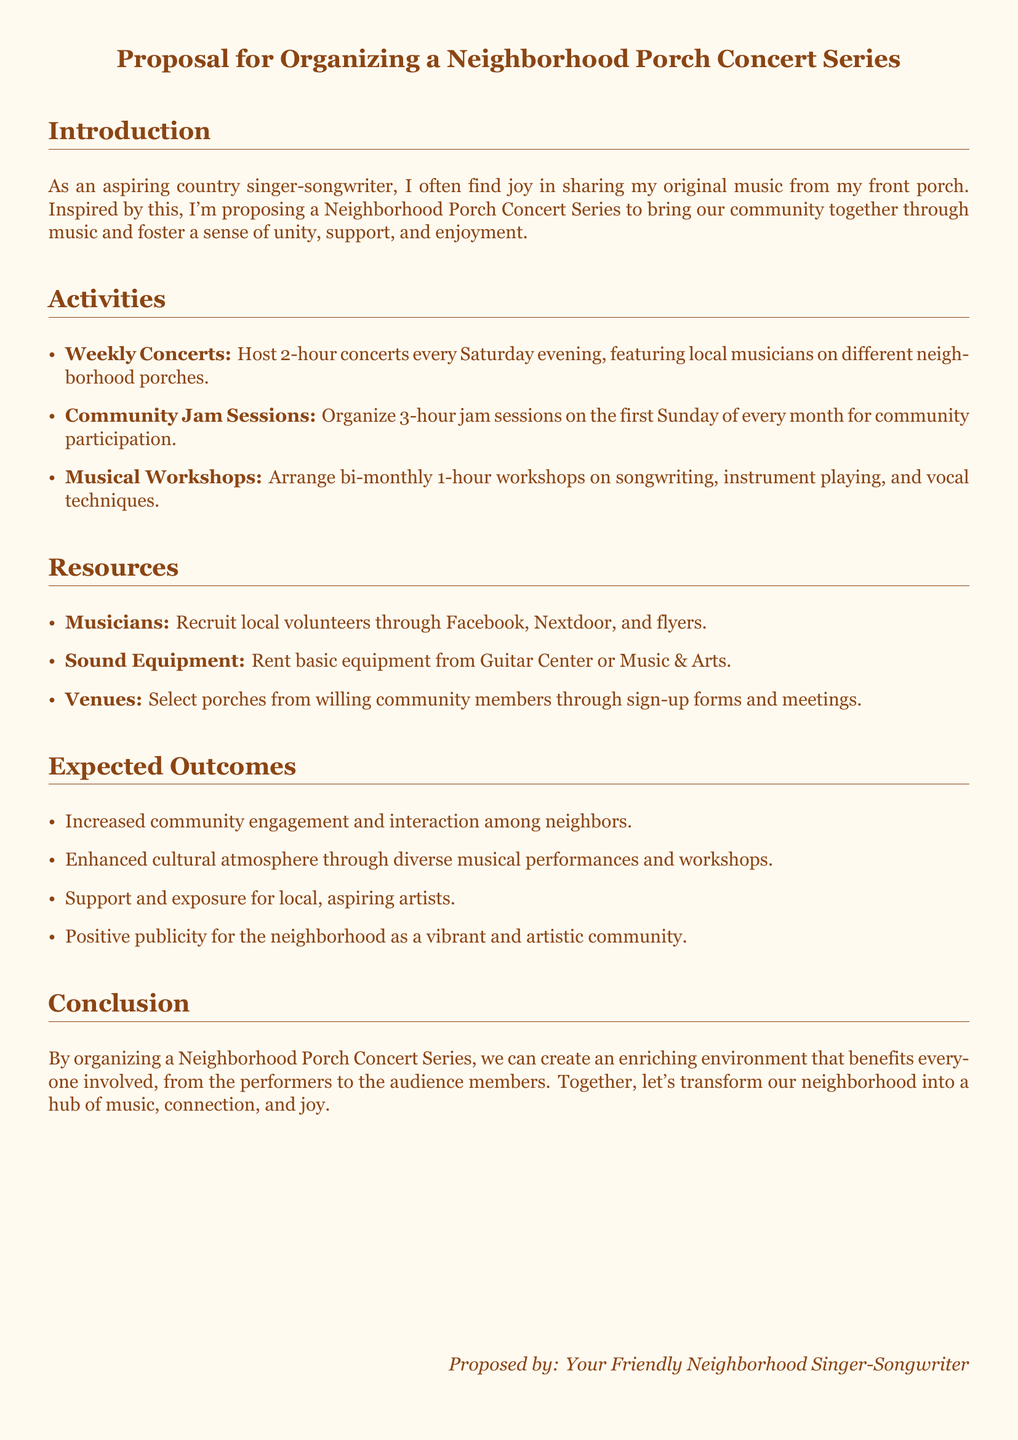What is the purpose of the proposal? The purpose of the proposal is to bring the community together through music and foster a sense of unity, support, and enjoyment.
Answer: To bring the community together How many concerts are planned each Saturday? The document states that there will be 2-hour concerts every Saturday evening.
Answer: Weekly concerts What is the frequency of community jam sessions? Community jam sessions are organized on the first Sunday of every month.
Answer: Monthly What type of workshops will be conducted? The workshops will focus on songwriting, instrument playing, and vocal techniques.
Answer: Musical workshops How does the proposal expect to enhance community engagement? The proposal expects to increase engagement through diverse musical performances and workshops, enhancing interaction among neighbors.
Answer: Increased engagement What is listed as a resource for recruiting musicians? The proposal suggests using Facebook, Nextdoor, and flyers to recruit local musicians.
Answer: Facebook, Nextdoor, flyers What is the duration of each musical workshop? Each musical workshop will last for 1 hour.
Answer: 1 hour Who proposed the concert series? The concert series was proposed by the friendly neighborhood singer-songwriter.
Answer: Your Friendly Neighborhood Singer-Songwriter What is the expected impact on local artists? The proposal outlines that it will provide support and exposure for local, aspiring artists.
Answer: Support for local artists 